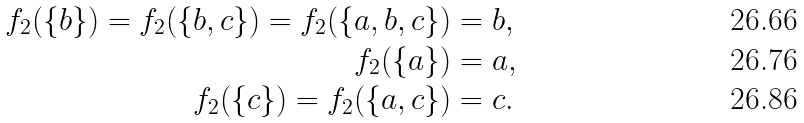<formula> <loc_0><loc_0><loc_500><loc_500>f _ { 2 } ( \{ b \} ) = f _ { 2 } ( \{ b , c \} ) = f _ { 2 } ( \{ a , b , c \} ) & = b , \\ f _ { 2 } ( \{ a \} ) & = a , \\ f _ { 2 } ( \{ c \} ) = f _ { 2 } ( \{ a , c \} ) & = c .</formula> 